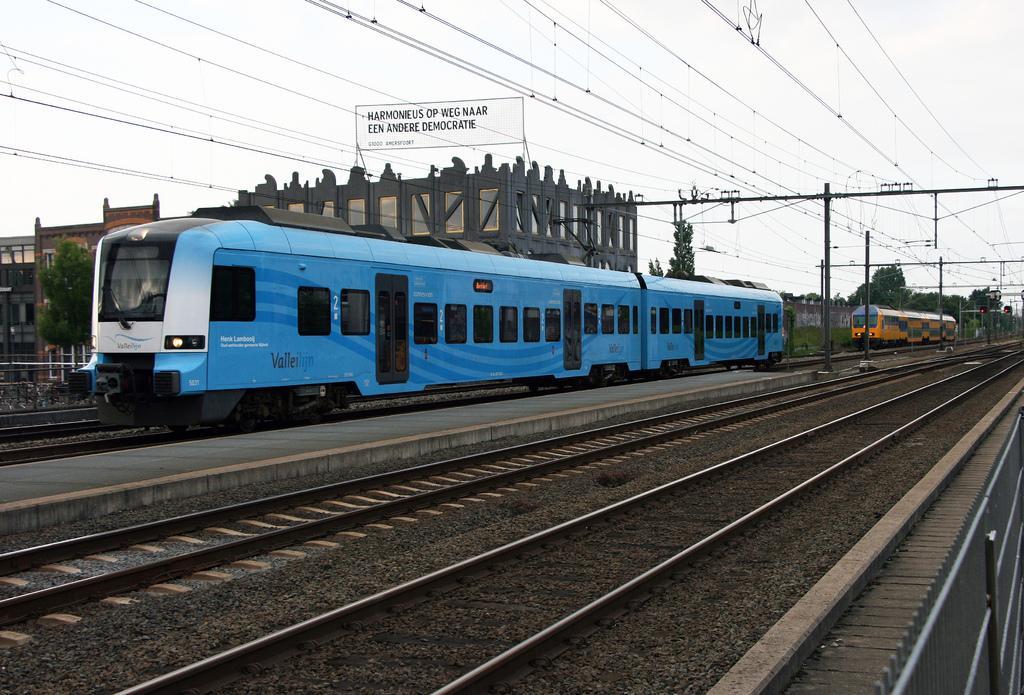Describe this image in one or two sentences. In this image I can see number of railway tracks and in the background I can see two trains on these tracks. I can also see a platform in the centre and in the background I can see few buildings, number of poles, number of wires, number of trees and on the top side of this image I can see something is written. 